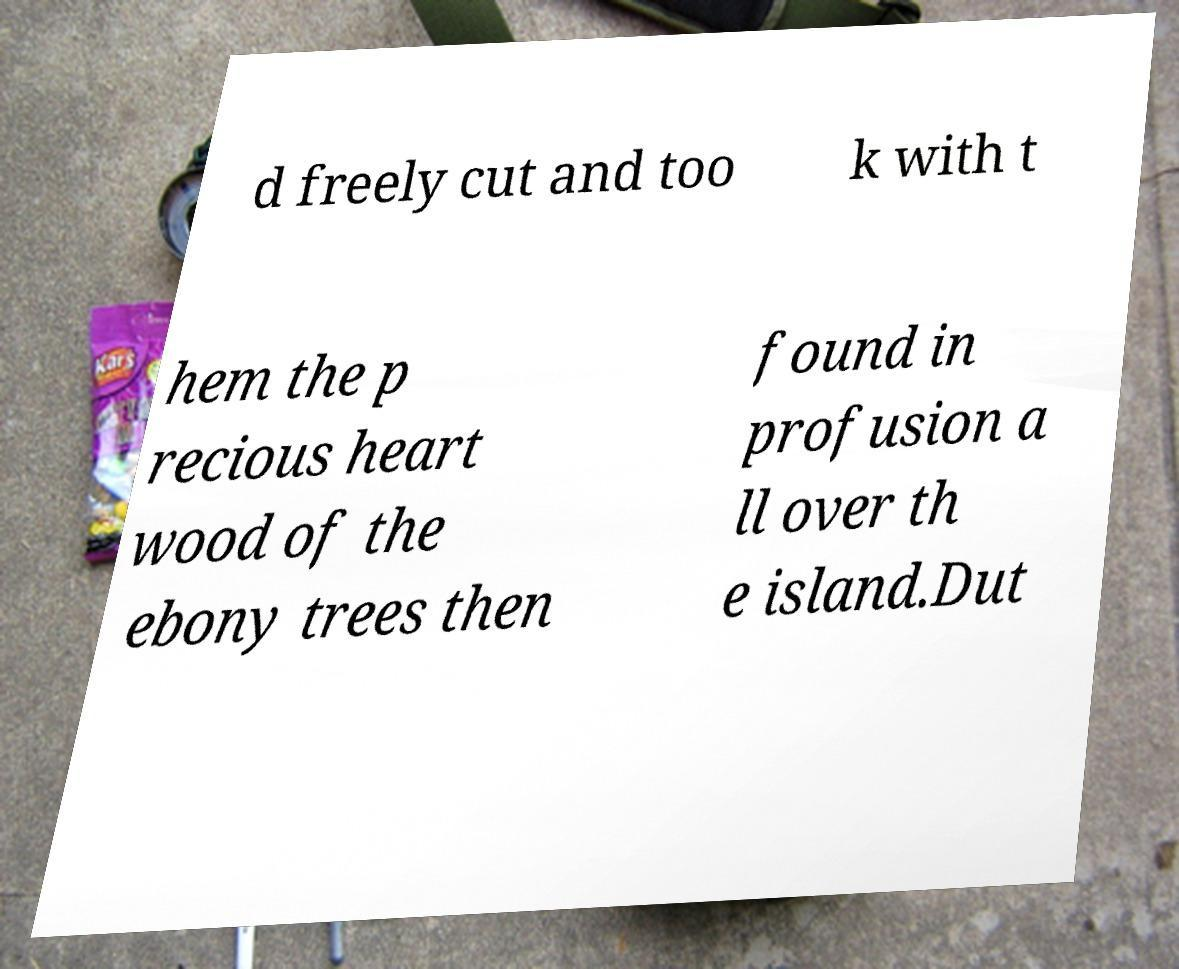Can you read and provide the text displayed in the image?This photo seems to have some interesting text. Can you extract and type it out for me? d freely cut and too k with t hem the p recious heart wood of the ebony trees then found in profusion a ll over th e island.Dut 